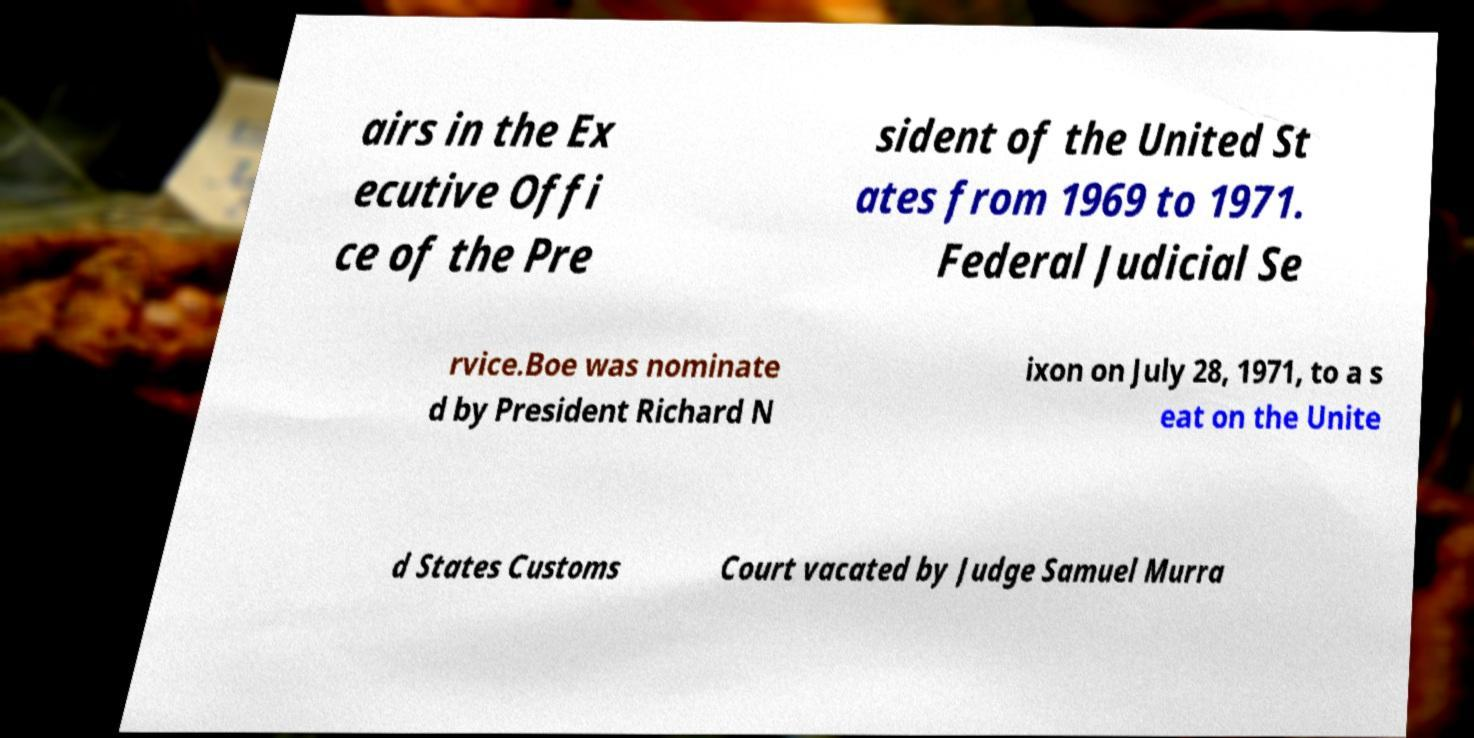Could you assist in decoding the text presented in this image and type it out clearly? airs in the Ex ecutive Offi ce of the Pre sident of the United St ates from 1969 to 1971. Federal Judicial Se rvice.Boe was nominate d by President Richard N ixon on July 28, 1971, to a s eat on the Unite d States Customs Court vacated by Judge Samuel Murra 